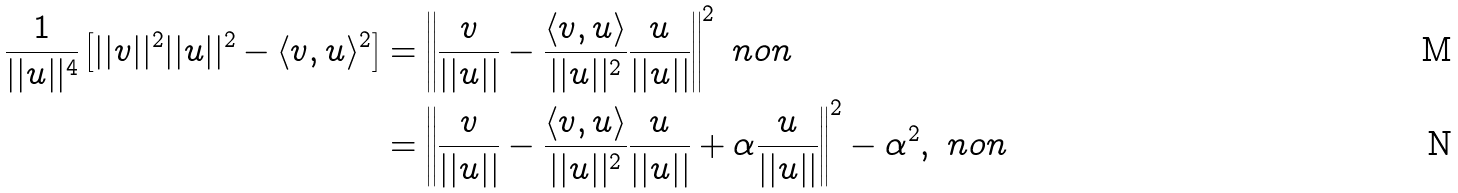<formula> <loc_0><loc_0><loc_500><loc_500>\frac { 1 } { | | u | | ^ { 4 } } \left [ | | v | | ^ { 2 } | | u | | ^ { 2 } - \langle v , u \rangle ^ { 2 } \right ] & = \left | \left | \frac { v } { | | u | | } - \frac { \langle v , u \rangle } { | | u | | ^ { 2 } } \frac { u } { | | u | | } \right | \right | ^ { 2 } \ n o n \\ & = \left | \left | \frac { v } { | | u | | } - \frac { \langle v , u \rangle } { | | u | | ^ { 2 } } \frac { u } { | | u | | } + \alpha \frac { u } { | | u | | } \right | \right | ^ { 2 } - \alpha ^ { 2 } , \ n o n</formula> 